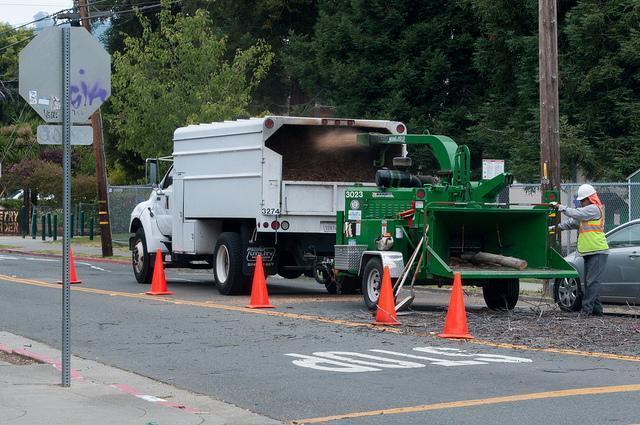How many bicycle tires are visible?
Give a very brief answer. 0. 